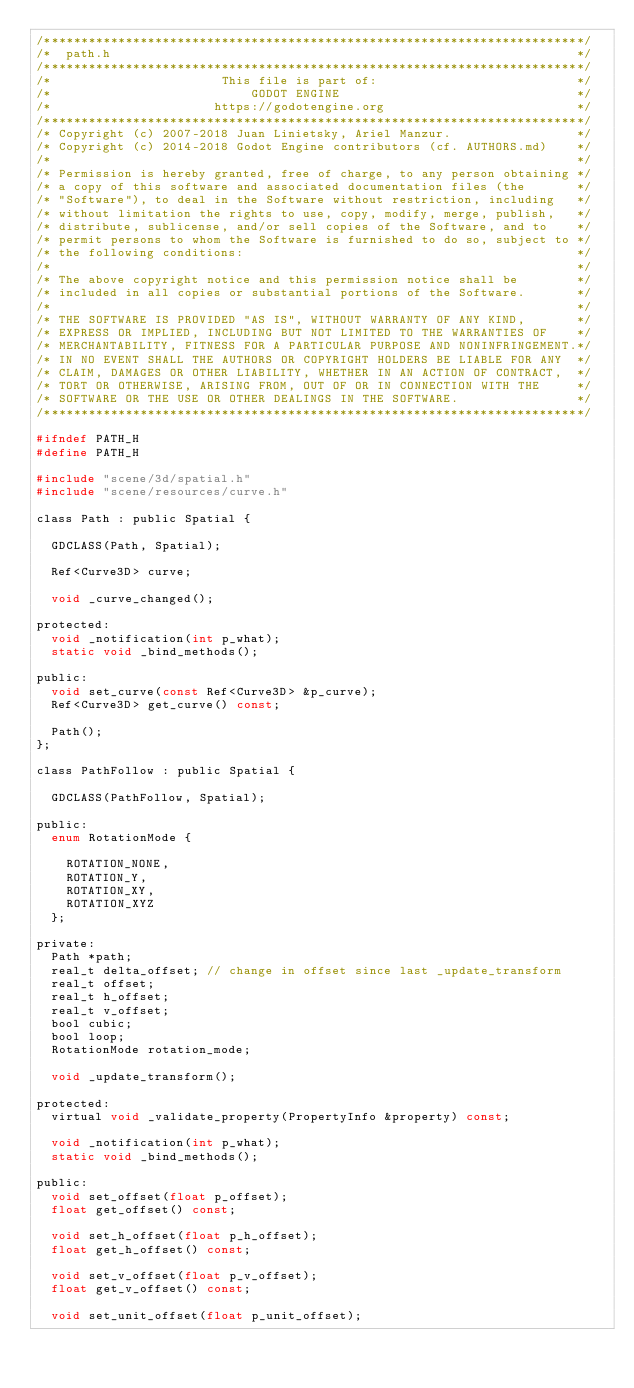Convert code to text. <code><loc_0><loc_0><loc_500><loc_500><_C_>/*************************************************************************/
/*  path.h                                                               */
/*************************************************************************/
/*                       This file is part of:                           */
/*                           GODOT ENGINE                                */
/*                      https://godotengine.org                          */
/*************************************************************************/
/* Copyright (c) 2007-2018 Juan Linietsky, Ariel Manzur.                 */
/* Copyright (c) 2014-2018 Godot Engine contributors (cf. AUTHORS.md)    */
/*                                                                       */
/* Permission is hereby granted, free of charge, to any person obtaining */
/* a copy of this software and associated documentation files (the       */
/* "Software"), to deal in the Software without restriction, including   */
/* without limitation the rights to use, copy, modify, merge, publish,   */
/* distribute, sublicense, and/or sell copies of the Software, and to    */
/* permit persons to whom the Software is furnished to do so, subject to */
/* the following conditions:                                             */
/*                                                                       */
/* The above copyright notice and this permission notice shall be        */
/* included in all copies or substantial portions of the Software.       */
/*                                                                       */
/* THE SOFTWARE IS PROVIDED "AS IS", WITHOUT WARRANTY OF ANY KIND,       */
/* EXPRESS OR IMPLIED, INCLUDING BUT NOT LIMITED TO THE WARRANTIES OF    */
/* MERCHANTABILITY, FITNESS FOR A PARTICULAR PURPOSE AND NONINFRINGEMENT.*/
/* IN NO EVENT SHALL THE AUTHORS OR COPYRIGHT HOLDERS BE LIABLE FOR ANY  */
/* CLAIM, DAMAGES OR OTHER LIABILITY, WHETHER IN AN ACTION OF CONTRACT,  */
/* TORT OR OTHERWISE, ARISING FROM, OUT OF OR IN CONNECTION WITH THE     */
/* SOFTWARE OR THE USE OR OTHER DEALINGS IN THE SOFTWARE.                */
/*************************************************************************/

#ifndef PATH_H
#define PATH_H

#include "scene/3d/spatial.h"
#include "scene/resources/curve.h"

class Path : public Spatial {

	GDCLASS(Path, Spatial);

	Ref<Curve3D> curve;

	void _curve_changed();

protected:
	void _notification(int p_what);
	static void _bind_methods();

public:
	void set_curve(const Ref<Curve3D> &p_curve);
	Ref<Curve3D> get_curve() const;

	Path();
};

class PathFollow : public Spatial {

	GDCLASS(PathFollow, Spatial);

public:
	enum RotationMode {

		ROTATION_NONE,
		ROTATION_Y,
		ROTATION_XY,
		ROTATION_XYZ
	};

private:
	Path *path;
	real_t delta_offset; // change in offset since last _update_transform
	real_t offset;
	real_t h_offset;
	real_t v_offset;
	bool cubic;
	bool loop;
	RotationMode rotation_mode;

	void _update_transform();

protected:
	virtual void _validate_property(PropertyInfo &property) const;

	void _notification(int p_what);
	static void _bind_methods();

public:
	void set_offset(float p_offset);
	float get_offset() const;

	void set_h_offset(float p_h_offset);
	float get_h_offset() const;

	void set_v_offset(float p_v_offset);
	float get_v_offset() const;

	void set_unit_offset(float p_unit_offset);</code> 